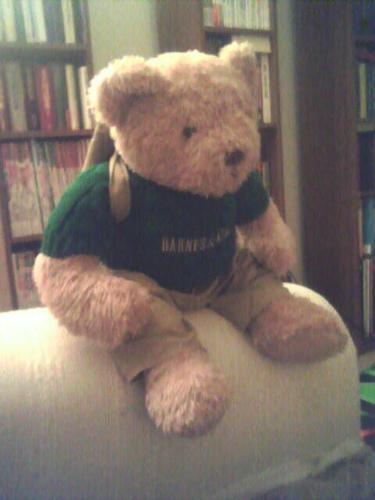How many books can be seen?
Give a very brief answer. 2. How many people are in the room?
Give a very brief answer. 0. 